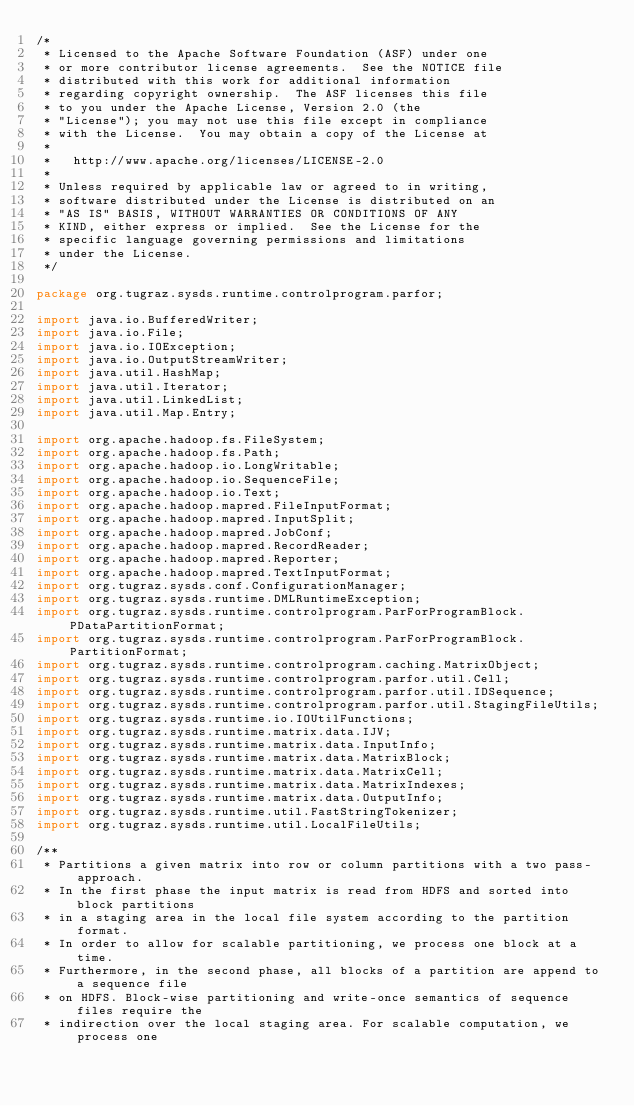Convert code to text. <code><loc_0><loc_0><loc_500><loc_500><_Java_>/*
 * Licensed to the Apache Software Foundation (ASF) under one
 * or more contributor license agreements.  See the NOTICE file
 * distributed with this work for additional information
 * regarding copyright ownership.  The ASF licenses this file
 * to you under the Apache License, Version 2.0 (the
 * "License"); you may not use this file except in compliance
 * with the License.  You may obtain a copy of the License at
 * 
 *   http://www.apache.org/licenses/LICENSE-2.0
 * 
 * Unless required by applicable law or agreed to in writing,
 * software distributed under the License is distributed on an
 * "AS IS" BASIS, WITHOUT WARRANTIES OR CONDITIONS OF ANY
 * KIND, either express or implied.  See the License for the
 * specific language governing permissions and limitations
 * under the License.
 */

package org.tugraz.sysds.runtime.controlprogram.parfor;

import java.io.BufferedWriter;
import java.io.File;
import java.io.IOException;
import java.io.OutputStreamWriter;
import java.util.HashMap;
import java.util.Iterator;
import java.util.LinkedList;
import java.util.Map.Entry;

import org.apache.hadoop.fs.FileSystem;
import org.apache.hadoop.fs.Path;
import org.apache.hadoop.io.LongWritable;
import org.apache.hadoop.io.SequenceFile;
import org.apache.hadoop.io.Text;
import org.apache.hadoop.mapred.FileInputFormat;
import org.apache.hadoop.mapred.InputSplit;
import org.apache.hadoop.mapred.JobConf;
import org.apache.hadoop.mapred.RecordReader;
import org.apache.hadoop.mapred.Reporter;
import org.apache.hadoop.mapred.TextInputFormat;
import org.tugraz.sysds.conf.ConfigurationManager;
import org.tugraz.sysds.runtime.DMLRuntimeException;
import org.tugraz.sysds.runtime.controlprogram.ParForProgramBlock.PDataPartitionFormat;
import org.tugraz.sysds.runtime.controlprogram.ParForProgramBlock.PartitionFormat;
import org.tugraz.sysds.runtime.controlprogram.caching.MatrixObject;
import org.tugraz.sysds.runtime.controlprogram.parfor.util.Cell;
import org.tugraz.sysds.runtime.controlprogram.parfor.util.IDSequence;
import org.tugraz.sysds.runtime.controlprogram.parfor.util.StagingFileUtils;
import org.tugraz.sysds.runtime.io.IOUtilFunctions;
import org.tugraz.sysds.runtime.matrix.data.IJV;
import org.tugraz.sysds.runtime.matrix.data.InputInfo;
import org.tugraz.sysds.runtime.matrix.data.MatrixBlock;
import org.tugraz.sysds.runtime.matrix.data.MatrixCell;
import org.tugraz.sysds.runtime.matrix.data.MatrixIndexes;
import org.tugraz.sysds.runtime.matrix.data.OutputInfo;
import org.tugraz.sysds.runtime.util.FastStringTokenizer;
import org.tugraz.sysds.runtime.util.LocalFileUtils;

/**
 * Partitions a given matrix into row or column partitions with a two pass-approach.
 * In the first phase the input matrix is read from HDFS and sorted into block partitions
 * in a staging area in the local file system according to the partition format. 
 * In order to allow for scalable partitioning, we process one block at a time. 
 * Furthermore, in the second phase, all blocks of a partition are append to a sequence file
 * on HDFS. Block-wise partitioning and write-once semantics of sequence files require the
 * indirection over the local staging area. For scalable computation, we process one </code> 